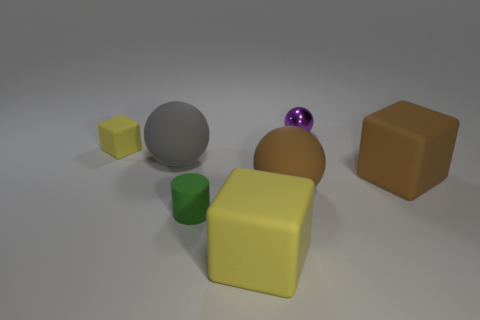Subtract all large brown matte blocks. How many blocks are left? 2 Add 2 big brown matte things. How many objects exist? 9 Subtract all gray spheres. How many spheres are left? 2 Subtract 1 balls. How many balls are left? 2 Subtract all cylinders. How many objects are left? 6 Subtract all large gray objects. Subtract all gray matte objects. How many objects are left? 5 Add 7 yellow rubber things. How many yellow rubber things are left? 9 Add 4 large brown spheres. How many large brown spheres exist? 5 Subtract 1 brown cubes. How many objects are left? 6 Subtract all cyan cylinders. Subtract all brown spheres. How many cylinders are left? 1 